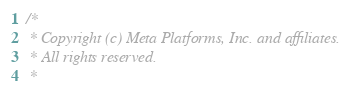Convert code to text. <code><loc_0><loc_0><loc_500><loc_500><_C_>/*
 * Copyright (c) Meta Platforms, Inc. and affiliates.
 * All rights reserved.
 *</code> 